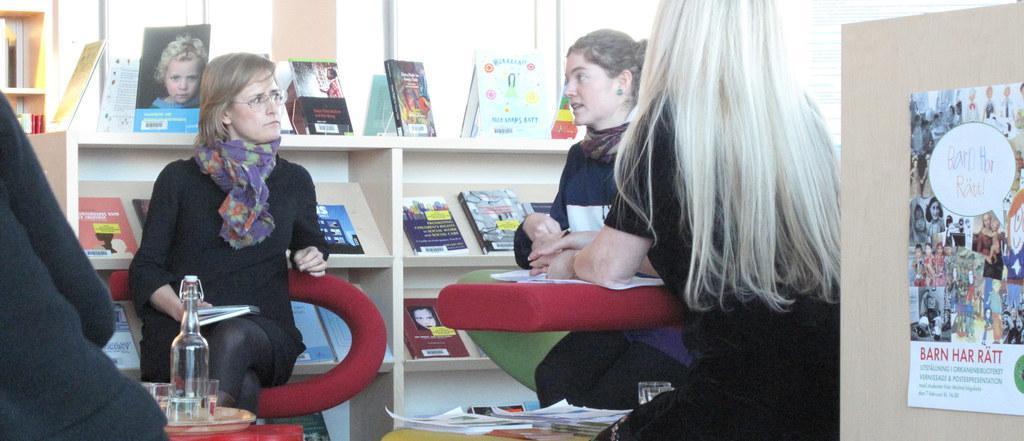How would you summarize this image in a sentence or two? In the middle of this image there are three women sitting on the chairs. At the bottom there are two tables on which a tray, bottle, glasses and papers are placed. On the left side there is a person. On the right side there is a board on which a poster is attached. On the poster, I can see some text and few images of persons. In the background there are few books arranged in the racks. 